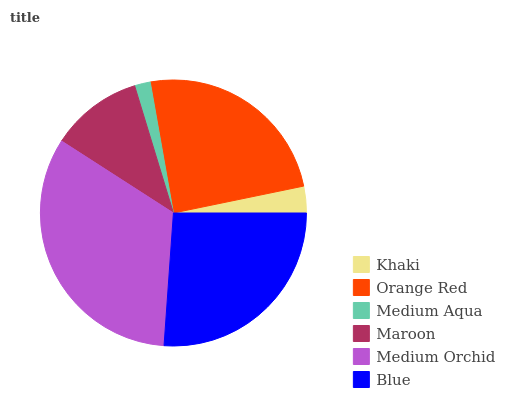Is Medium Aqua the minimum?
Answer yes or no. Yes. Is Medium Orchid the maximum?
Answer yes or no. Yes. Is Orange Red the minimum?
Answer yes or no. No. Is Orange Red the maximum?
Answer yes or no. No. Is Orange Red greater than Khaki?
Answer yes or no. Yes. Is Khaki less than Orange Red?
Answer yes or no. Yes. Is Khaki greater than Orange Red?
Answer yes or no. No. Is Orange Red less than Khaki?
Answer yes or no. No. Is Orange Red the high median?
Answer yes or no. Yes. Is Maroon the low median?
Answer yes or no. Yes. Is Maroon the high median?
Answer yes or no. No. Is Orange Red the low median?
Answer yes or no. No. 